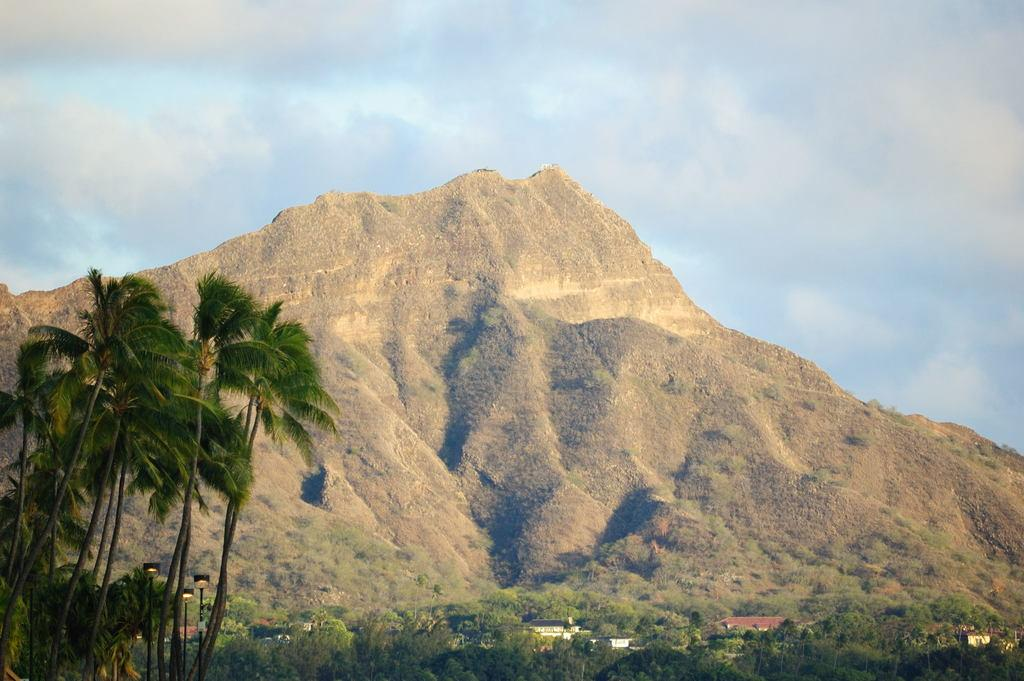What type of natural elements can be seen in the image? There are trees in the image. What man-made structures are visible in the image? There are poles and houses in the image. What geographical features can be observed in the image? There are hills in the image. Where is the chair located in the image? There is no chair present in the image. What type of drink is being served in the prison in the image? There is no prison or drink mentioned in the image; it features trees, poles, houses, and hills. 